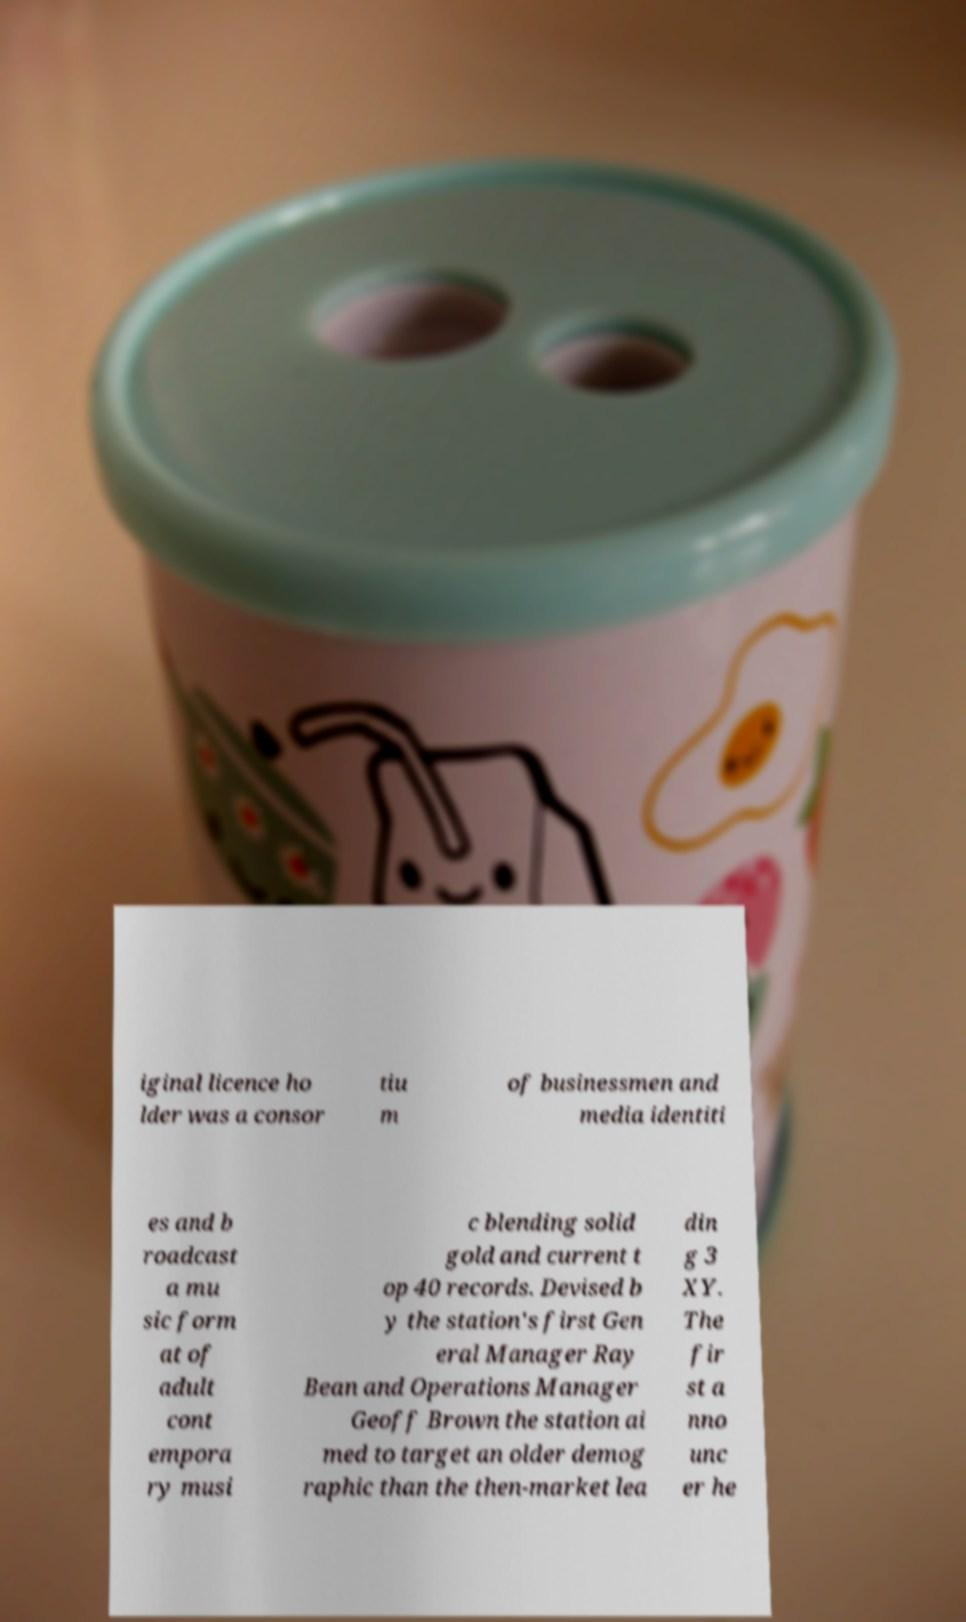Can you accurately transcribe the text from the provided image for me? iginal licence ho lder was a consor tiu m of businessmen and media identiti es and b roadcast a mu sic form at of adult cont empora ry musi c blending solid gold and current t op 40 records. Devised b y the station's first Gen eral Manager Ray Bean and Operations Manager Geoff Brown the station ai med to target an older demog raphic than the then-market lea din g 3 XY. The fir st a nno unc er he 